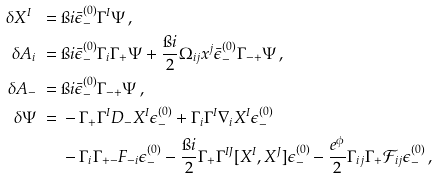Convert formula to latex. <formula><loc_0><loc_0><loc_500><loc_500>\delta X ^ { I } \ = & \ \i i \bar { \epsilon } ^ { ( 0 ) } _ { - } \Gamma ^ { I } \Psi \, , \\ \delta A _ { i } \ = & \ \i i \bar { \epsilon } ^ { ( 0 ) } _ { - } \Gamma _ { i } \Gamma _ { + } \Psi + \frac { \i i } { 2 } \Omega _ { i j } x ^ { j } \bar { \epsilon } ^ { ( 0 ) } _ { - } \Gamma _ { - + } \Psi \, , \\ \delta A _ { - } \ = & \ \i i \bar { \epsilon } ^ { ( 0 ) } _ { - } \Gamma _ { - + } \Psi \, , \\ \delta \Psi \ = & \ - \Gamma _ { + } \Gamma ^ { I } D _ { - } X ^ { I } \epsilon ^ { ( 0 ) } _ { - } + \Gamma _ { i } \Gamma ^ { I } \nabla _ { i } X ^ { I } \epsilon ^ { ( 0 ) } _ { - } \\ & \ - \Gamma _ { i } \Gamma _ { + - } F _ { - i } \epsilon ^ { ( 0 ) } _ { - } - \frac { \i i } { 2 } \Gamma _ { + } \Gamma ^ { I J } [ X ^ { I } , X ^ { J } ] \epsilon ^ { ( 0 ) } _ { - } - \frac { e ^ { \phi } } { 2 } \Gamma _ { i j } \Gamma _ { + } \mathcal { F } _ { i j } \epsilon ^ { ( 0 ) } _ { - } \, ,</formula> 